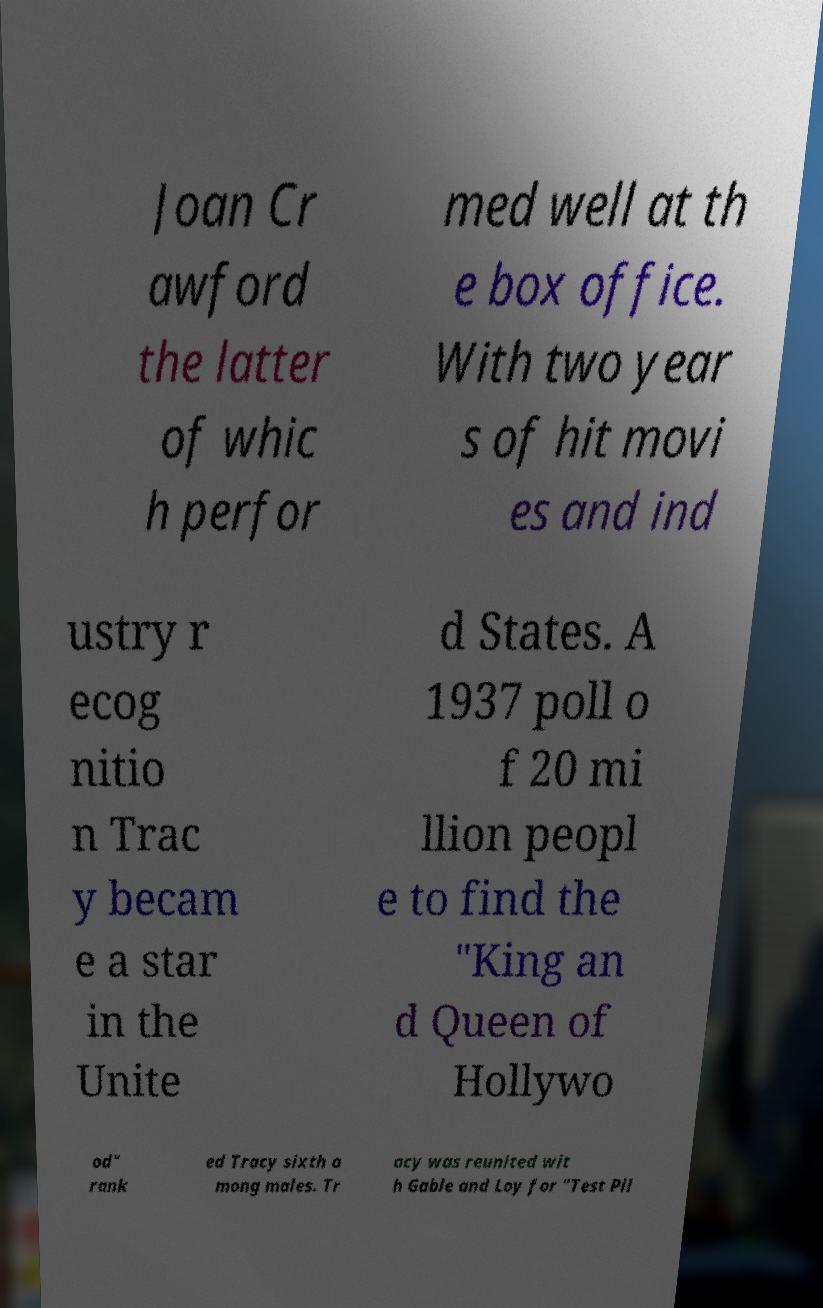Please identify and transcribe the text found in this image. Joan Cr awford the latter of whic h perfor med well at th e box office. With two year s of hit movi es and ind ustry r ecog nitio n Trac y becam e a star in the Unite d States. A 1937 poll o f 20 mi llion peopl e to find the "King an d Queen of Hollywo od" rank ed Tracy sixth a mong males. Tr acy was reunited wit h Gable and Loy for "Test Pil 